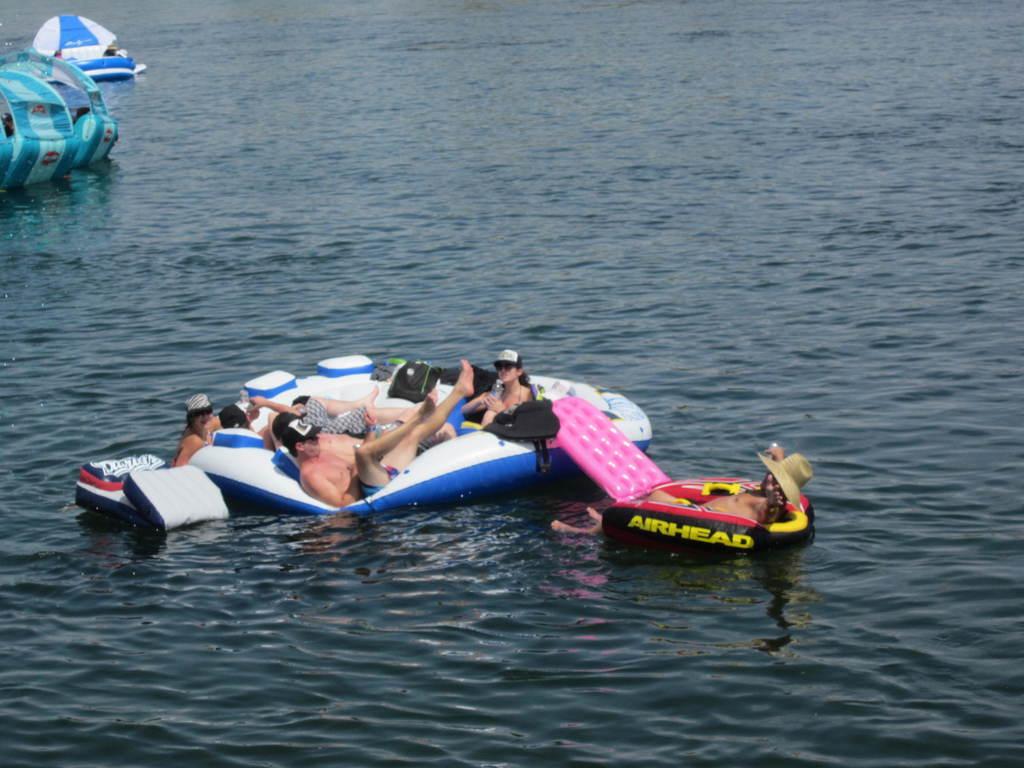What is the name on the raft?
Your response must be concise. Airhead. 